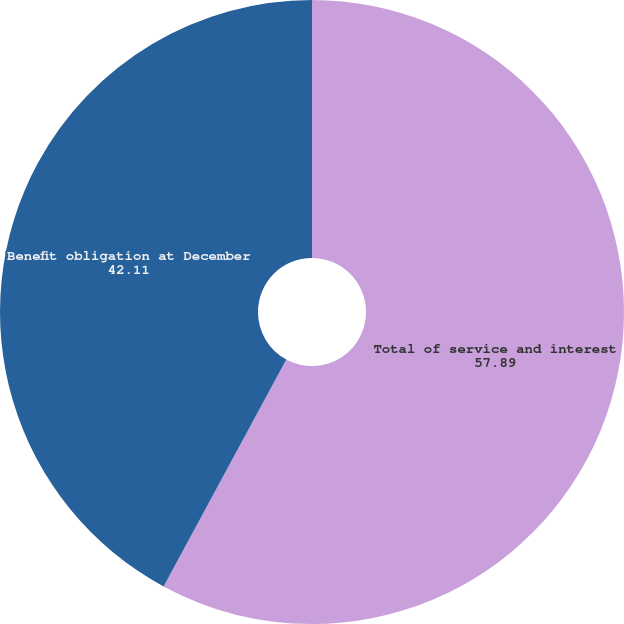Convert chart. <chart><loc_0><loc_0><loc_500><loc_500><pie_chart><fcel>Total of service and interest<fcel>Benefit obligation at December<nl><fcel>57.89%<fcel>42.11%<nl></chart> 